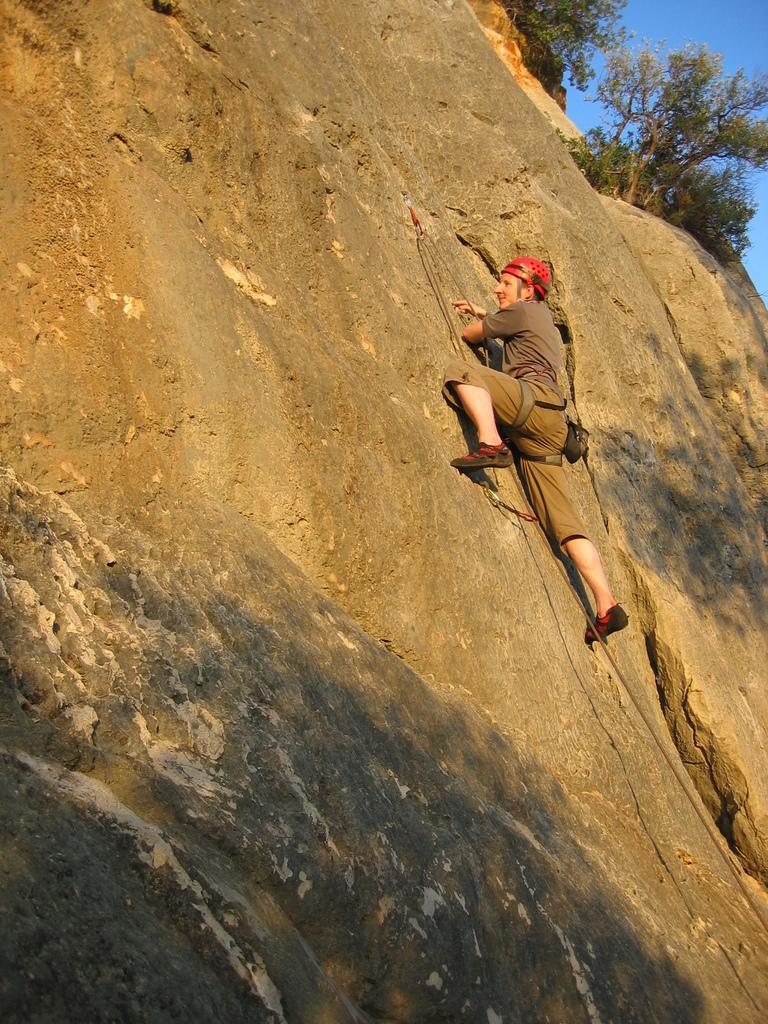Who is the main subject in the image? There is a man in the image. What is the man doing in the image? The man is climbing on a mountain. What type of vegetation can be seen in the image? There are trees visible in the image. What is the color of the sky in the image? The sky is blue in the image. Where is the market located in the image? There is no market present in the image. How many women are visible in the image? There are no women visible in the image. 